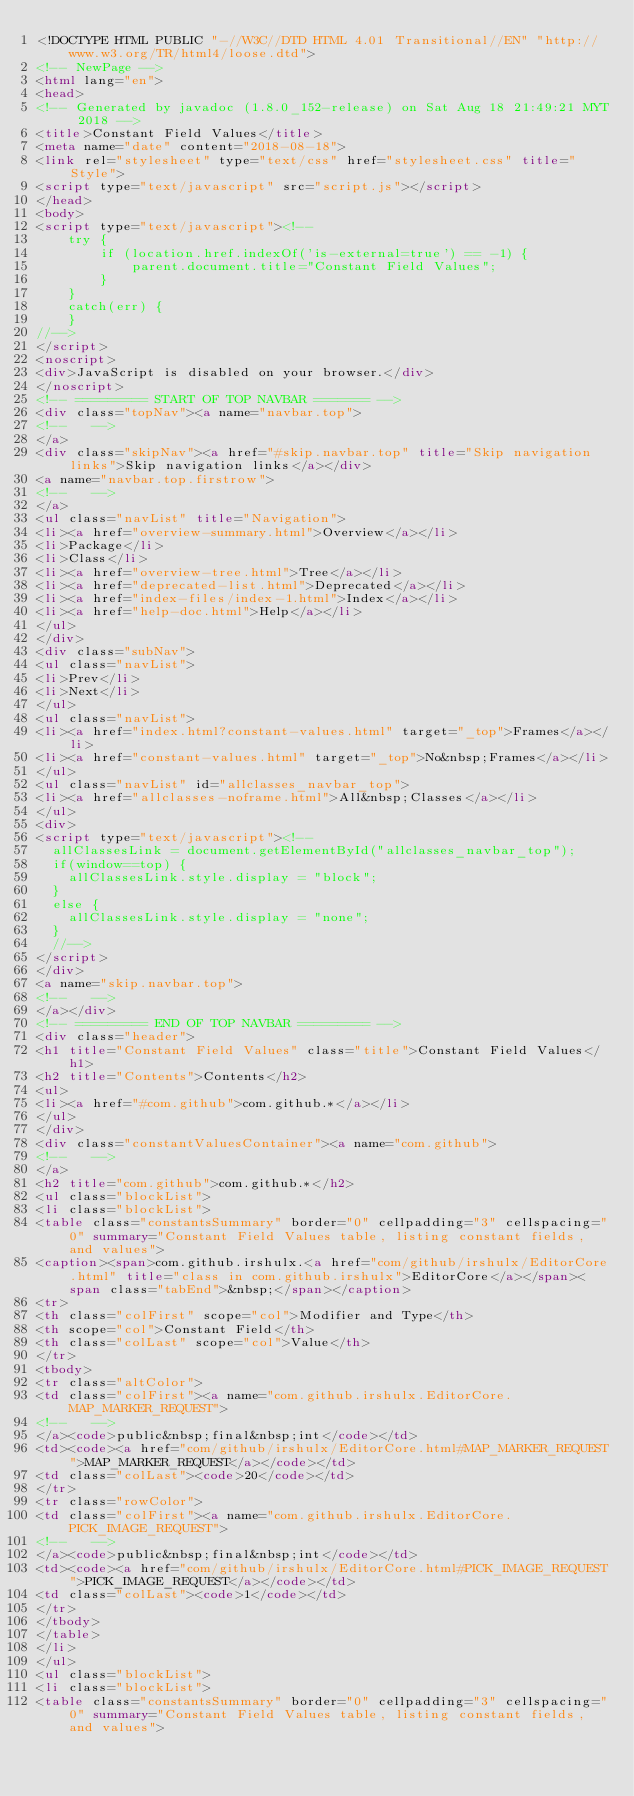<code> <loc_0><loc_0><loc_500><loc_500><_HTML_><!DOCTYPE HTML PUBLIC "-//W3C//DTD HTML 4.01 Transitional//EN" "http://www.w3.org/TR/html4/loose.dtd">
<!-- NewPage -->
<html lang="en">
<head>
<!-- Generated by javadoc (1.8.0_152-release) on Sat Aug 18 21:49:21 MYT 2018 -->
<title>Constant Field Values</title>
<meta name="date" content="2018-08-18">
<link rel="stylesheet" type="text/css" href="stylesheet.css" title="Style">
<script type="text/javascript" src="script.js"></script>
</head>
<body>
<script type="text/javascript"><!--
    try {
        if (location.href.indexOf('is-external=true') == -1) {
            parent.document.title="Constant Field Values";
        }
    }
    catch(err) {
    }
//-->
</script>
<noscript>
<div>JavaScript is disabled on your browser.</div>
</noscript>
<!-- ========= START OF TOP NAVBAR ======= -->
<div class="topNav"><a name="navbar.top">
<!--   -->
</a>
<div class="skipNav"><a href="#skip.navbar.top" title="Skip navigation links">Skip navigation links</a></div>
<a name="navbar.top.firstrow">
<!--   -->
</a>
<ul class="navList" title="Navigation">
<li><a href="overview-summary.html">Overview</a></li>
<li>Package</li>
<li>Class</li>
<li><a href="overview-tree.html">Tree</a></li>
<li><a href="deprecated-list.html">Deprecated</a></li>
<li><a href="index-files/index-1.html">Index</a></li>
<li><a href="help-doc.html">Help</a></li>
</ul>
</div>
<div class="subNav">
<ul class="navList">
<li>Prev</li>
<li>Next</li>
</ul>
<ul class="navList">
<li><a href="index.html?constant-values.html" target="_top">Frames</a></li>
<li><a href="constant-values.html" target="_top">No&nbsp;Frames</a></li>
</ul>
<ul class="navList" id="allclasses_navbar_top">
<li><a href="allclasses-noframe.html">All&nbsp;Classes</a></li>
</ul>
<div>
<script type="text/javascript"><!--
  allClassesLink = document.getElementById("allclasses_navbar_top");
  if(window==top) {
    allClassesLink.style.display = "block";
  }
  else {
    allClassesLink.style.display = "none";
  }
  //-->
</script>
</div>
<a name="skip.navbar.top">
<!--   -->
</a></div>
<!-- ========= END OF TOP NAVBAR ========= -->
<div class="header">
<h1 title="Constant Field Values" class="title">Constant Field Values</h1>
<h2 title="Contents">Contents</h2>
<ul>
<li><a href="#com.github">com.github.*</a></li>
</ul>
</div>
<div class="constantValuesContainer"><a name="com.github">
<!--   -->
</a>
<h2 title="com.github">com.github.*</h2>
<ul class="blockList">
<li class="blockList">
<table class="constantsSummary" border="0" cellpadding="3" cellspacing="0" summary="Constant Field Values table, listing constant fields, and values">
<caption><span>com.github.irshulx.<a href="com/github/irshulx/EditorCore.html" title="class in com.github.irshulx">EditorCore</a></span><span class="tabEnd">&nbsp;</span></caption>
<tr>
<th class="colFirst" scope="col">Modifier and Type</th>
<th scope="col">Constant Field</th>
<th class="colLast" scope="col">Value</th>
</tr>
<tbody>
<tr class="altColor">
<td class="colFirst"><a name="com.github.irshulx.EditorCore.MAP_MARKER_REQUEST">
<!--   -->
</a><code>public&nbsp;final&nbsp;int</code></td>
<td><code><a href="com/github/irshulx/EditorCore.html#MAP_MARKER_REQUEST">MAP_MARKER_REQUEST</a></code></td>
<td class="colLast"><code>20</code></td>
</tr>
<tr class="rowColor">
<td class="colFirst"><a name="com.github.irshulx.EditorCore.PICK_IMAGE_REQUEST">
<!--   -->
</a><code>public&nbsp;final&nbsp;int</code></td>
<td><code><a href="com/github/irshulx/EditorCore.html#PICK_IMAGE_REQUEST">PICK_IMAGE_REQUEST</a></code></td>
<td class="colLast"><code>1</code></td>
</tr>
</tbody>
</table>
</li>
</ul>
<ul class="blockList">
<li class="blockList">
<table class="constantsSummary" border="0" cellpadding="3" cellspacing="0" summary="Constant Field Values table, listing constant fields, and values"></code> 